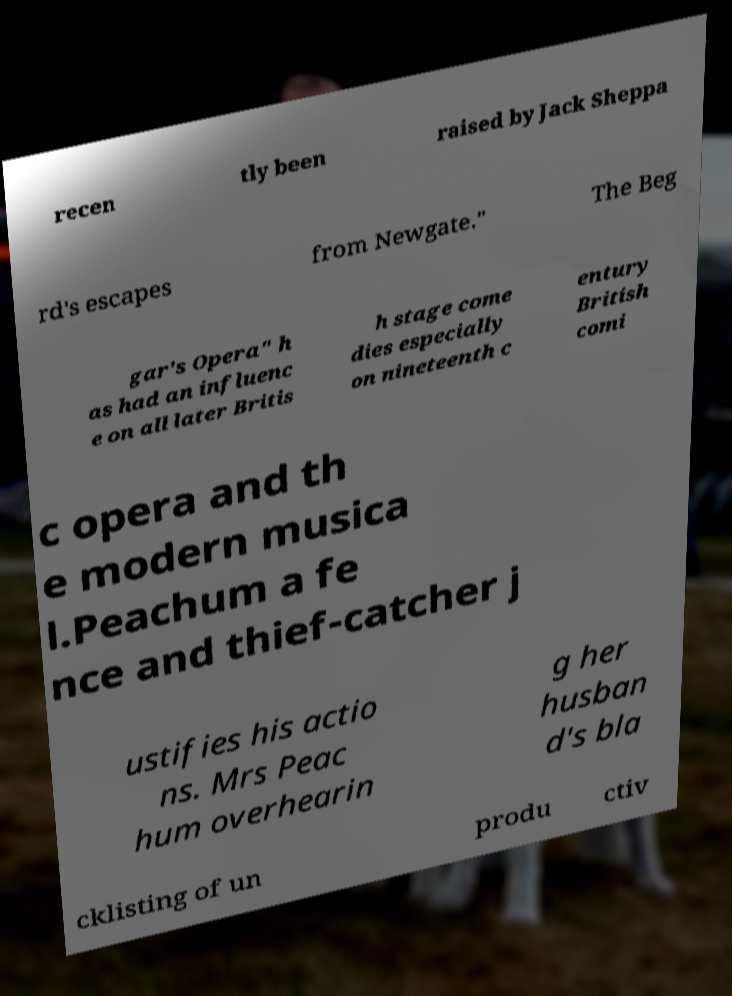I need the written content from this picture converted into text. Can you do that? recen tly been raised by Jack Sheppa rd's escapes from Newgate." The Beg gar's Opera" h as had an influenc e on all later Britis h stage come dies especially on nineteenth c entury British comi c opera and th e modern musica l.Peachum a fe nce and thief-catcher j ustifies his actio ns. Mrs Peac hum overhearin g her husban d's bla cklisting of un produ ctiv 